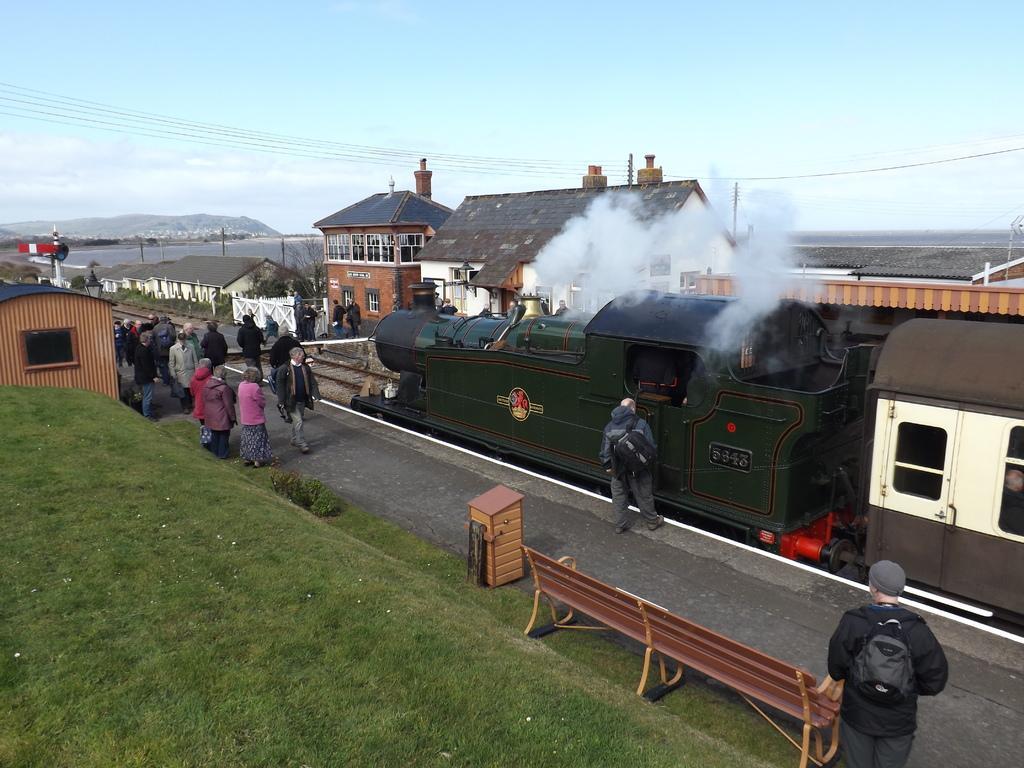Describe this image in one or two sentences. In this image we can see a train. This is the platform where people are standing. In the background we can see buildings, clouds and sky. 